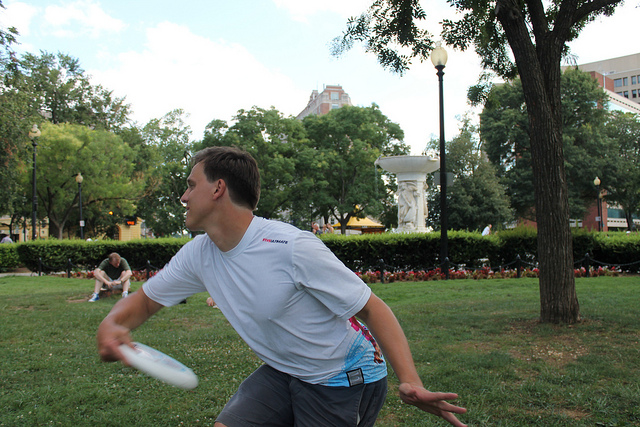<image>What is the color of the placemats? There are no placemats in the image. However, they can be white or green. What is the color of the placemats? The color of the placemats is ambiguous. It can be seen as white or green. 